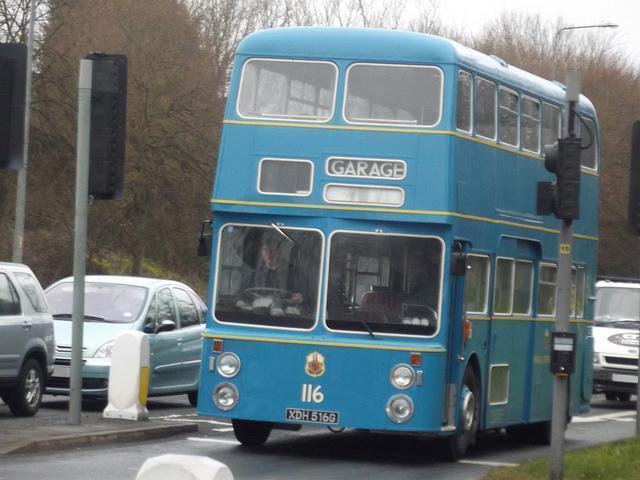Why is the bus without passengers?
Pick the right solution, then justify: 'Answer: answer
Rationale: rationale.'
Options: Passengers exiting, accident, garage bound, broken down. Answer: garage bound.
Rationale: The bus has a sign that says it is headed to the garage. 